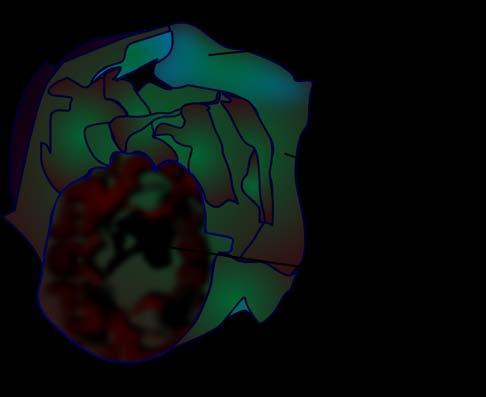does the anorectal margin show a very large multilocular cyst without papillae?
Answer the question using a single word or phrase. No 